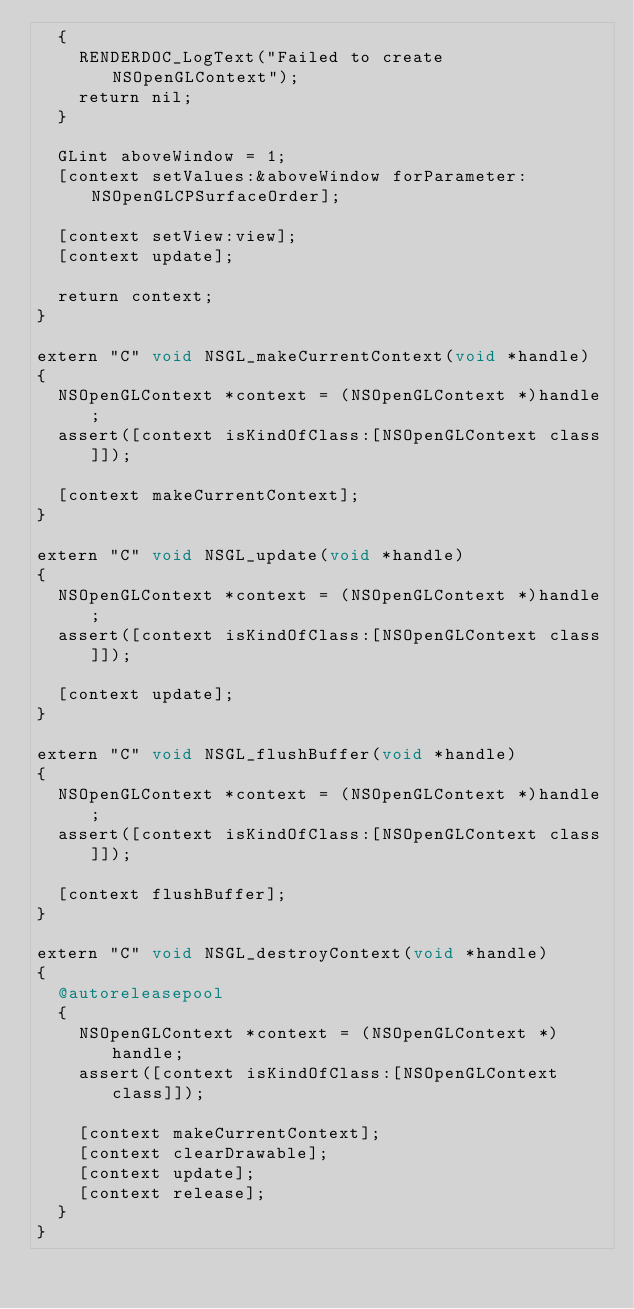Convert code to text. <code><loc_0><loc_0><loc_500><loc_500><_ObjectiveC_>  {
    RENDERDOC_LogText("Failed to create NSOpenGLContext");
    return nil;
  }

  GLint aboveWindow = 1;
  [context setValues:&aboveWindow forParameter:NSOpenGLCPSurfaceOrder];

  [context setView:view];
  [context update];

  return context;
}

extern "C" void NSGL_makeCurrentContext(void *handle)
{
  NSOpenGLContext *context = (NSOpenGLContext *)handle;
  assert([context isKindOfClass:[NSOpenGLContext class]]);

  [context makeCurrentContext];
}

extern "C" void NSGL_update(void *handle)
{
  NSOpenGLContext *context = (NSOpenGLContext *)handle;
  assert([context isKindOfClass:[NSOpenGLContext class]]);

  [context update];
}

extern "C" void NSGL_flushBuffer(void *handle)
{
  NSOpenGLContext *context = (NSOpenGLContext *)handle;
  assert([context isKindOfClass:[NSOpenGLContext class]]);

  [context flushBuffer];
}

extern "C" void NSGL_destroyContext(void *handle)
{
  @autoreleasepool
  {
    NSOpenGLContext *context = (NSOpenGLContext *)handle;
    assert([context isKindOfClass:[NSOpenGLContext class]]);

    [context makeCurrentContext];
    [context clearDrawable];
    [context update];
    [context release];
  }
}</code> 